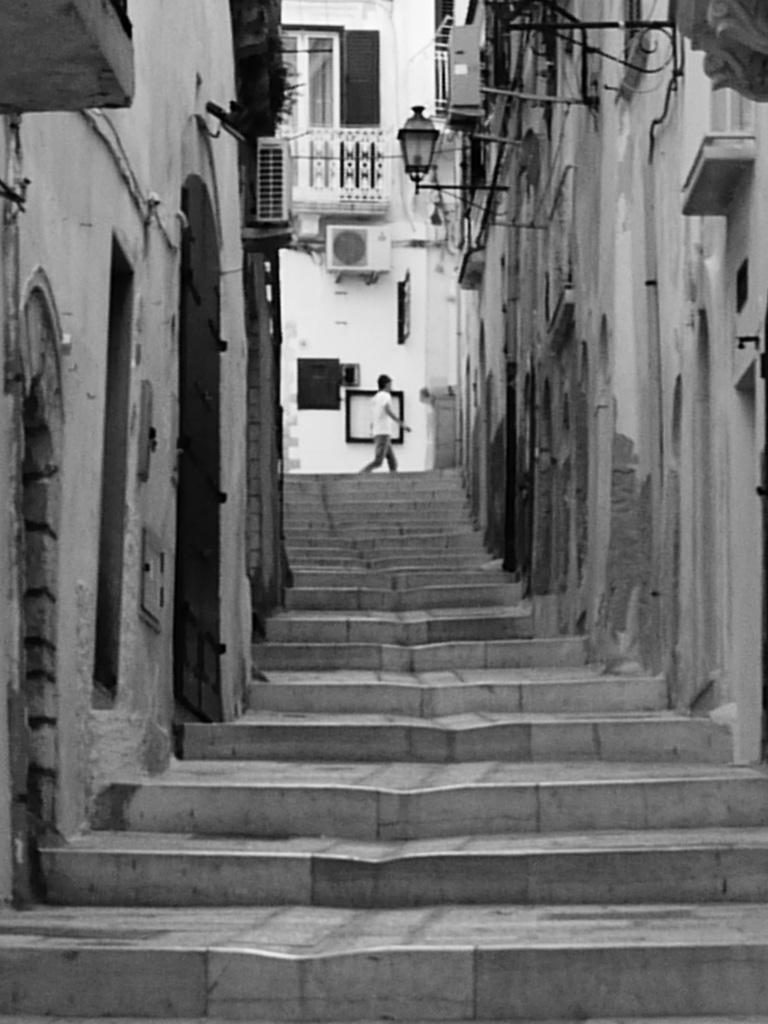Could you give a brief overview of what you see in this image? This is a black and white image. In this image there are steps. On the sides there are walls. On the wall there is a light lamp. In the back there is a person walking and also there is a building with windows and AC. 